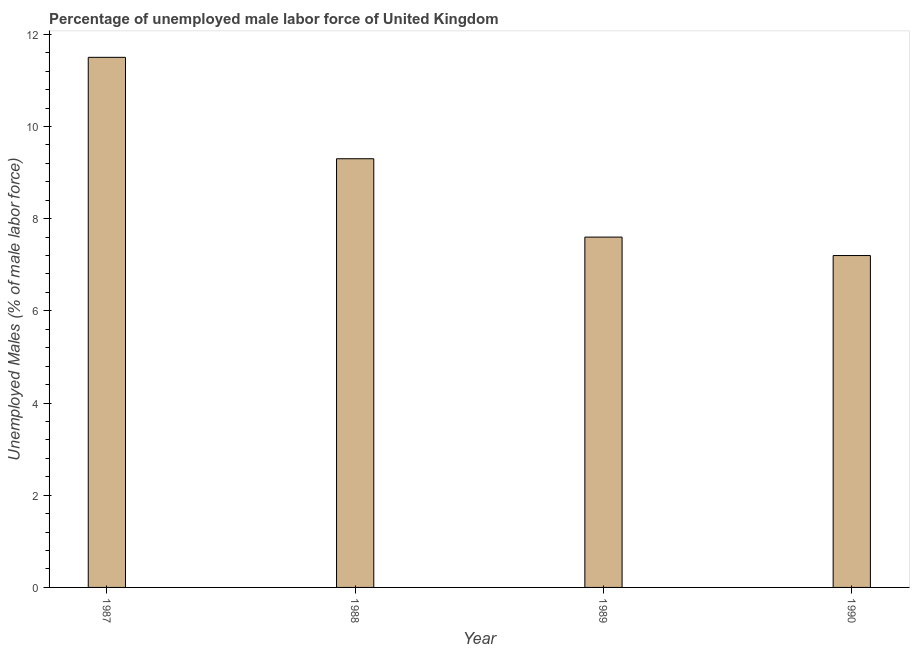What is the title of the graph?
Ensure brevity in your answer.  Percentage of unemployed male labor force of United Kingdom. What is the label or title of the Y-axis?
Your response must be concise. Unemployed Males (% of male labor force). What is the total unemployed male labour force in 1988?
Make the answer very short. 9.3. Across all years, what is the maximum total unemployed male labour force?
Your answer should be compact. 11.5. Across all years, what is the minimum total unemployed male labour force?
Ensure brevity in your answer.  7.2. In which year was the total unemployed male labour force maximum?
Keep it short and to the point. 1987. What is the sum of the total unemployed male labour force?
Provide a short and direct response. 35.6. What is the difference between the total unemployed male labour force in 1987 and 1990?
Provide a succinct answer. 4.3. What is the median total unemployed male labour force?
Provide a succinct answer. 8.45. What is the ratio of the total unemployed male labour force in 1989 to that in 1990?
Make the answer very short. 1.06. Is the total unemployed male labour force in 1988 less than that in 1989?
Keep it short and to the point. No. Is the difference between the total unemployed male labour force in 1988 and 1990 greater than the difference between any two years?
Provide a short and direct response. No. Is the sum of the total unemployed male labour force in 1988 and 1989 greater than the maximum total unemployed male labour force across all years?
Offer a very short reply. Yes. What is the difference between the highest and the lowest total unemployed male labour force?
Make the answer very short. 4.3. In how many years, is the total unemployed male labour force greater than the average total unemployed male labour force taken over all years?
Give a very brief answer. 2. Are all the bars in the graph horizontal?
Offer a very short reply. No. Are the values on the major ticks of Y-axis written in scientific E-notation?
Keep it short and to the point. No. What is the Unemployed Males (% of male labor force) in 1987?
Make the answer very short. 11.5. What is the Unemployed Males (% of male labor force) of 1988?
Keep it short and to the point. 9.3. What is the Unemployed Males (% of male labor force) of 1989?
Offer a very short reply. 7.6. What is the Unemployed Males (% of male labor force) in 1990?
Keep it short and to the point. 7.2. What is the difference between the Unemployed Males (% of male labor force) in 1987 and 1988?
Give a very brief answer. 2.2. What is the difference between the Unemployed Males (% of male labor force) in 1987 and 1989?
Offer a terse response. 3.9. What is the difference between the Unemployed Males (% of male labor force) in 1987 and 1990?
Offer a very short reply. 4.3. What is the difference between the Unemployed Males (% of male labor force) in 1988 and 1989?
Keep it short and to the point. 1.7. What is the difference between the Unemployed Males (% of male labor force) in 1988 and 1990?
Your answer should be very brief. 2.1. What is the ratio of the Unemployed Males (% of male labor force) in 1987 to that in 1988?
Offer a very short reply. 1.24. What is the ratio of the Unemployed Males (% of male labor force) in 1987 to that in 1989?
Keep it short and to the point. 1.51. What is the ratio of the Unemployed Males (% of male labor force) in 1987 to that in 1990?
Provide a succinct answer. 1.6. What is the ratio of the Unemployed Males (% of male labor force) in 1988 to that in 1989?
Provide a short and direct response. 1.22. What is the ratio of the Unemployed Males (% of male labor force) in 1988 to that in 1990?
Keep it short and to the point. 1.29. What is the ratio of the Unemployed Males (% of male labor force) in 1989 to that in 1990?
Your answer should be very brief. 1.06. 